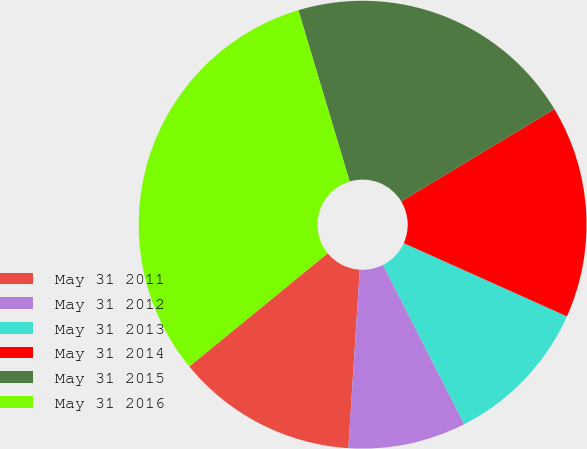<chart> <loc_0><loc_0><loc_500><loc_500><pie_chart><fcel>May 31 2011<fcel>May 31 2012<fcel>May 31 2013<fcel>May 31 2014<fcel>May 31 2015<fcel>May 31 2016<nl><fcel>13.07%<fcel>8.51%<fcel>10.79%<fcel>15.34%<fcel>21.0%<fcel>31.28%<nl></chart> 